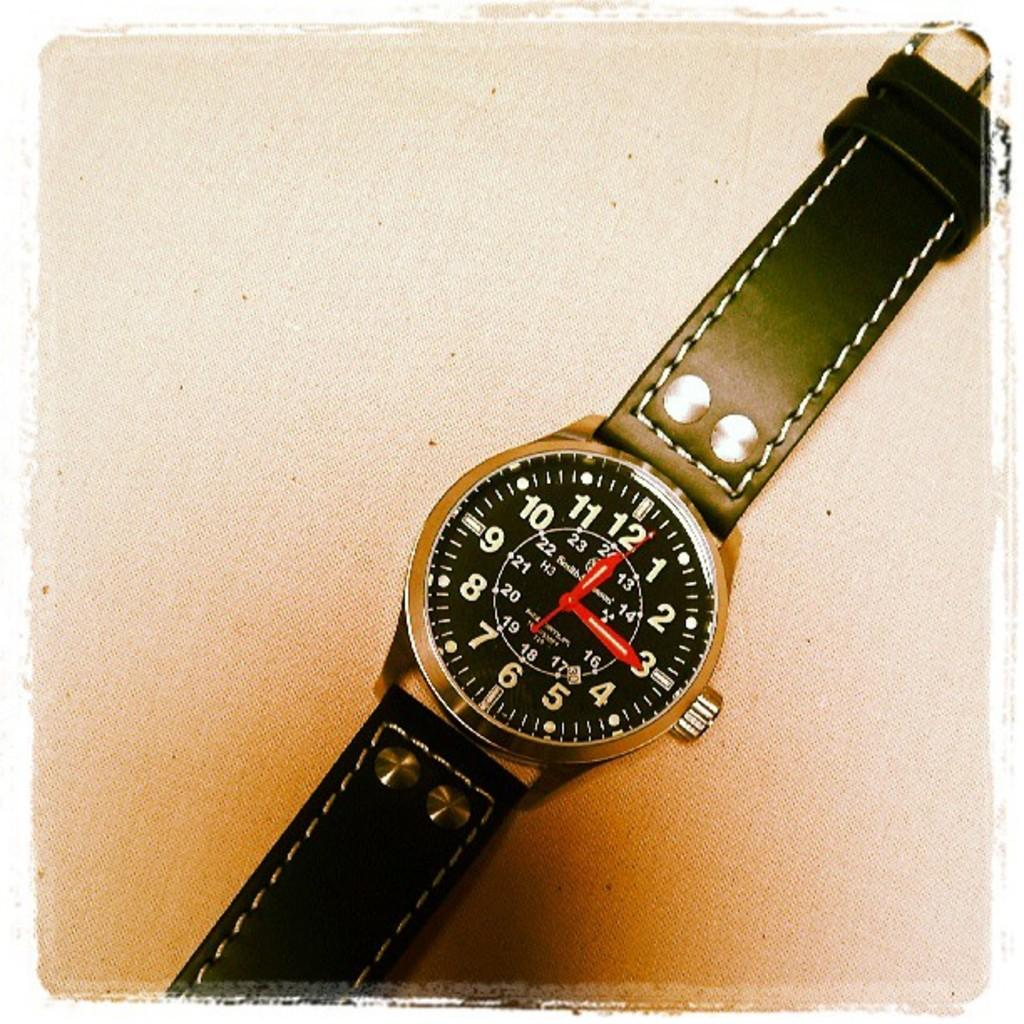<image>
Present a compact description of the photo's key features. A black wristwatch that has the time of 12:15. 